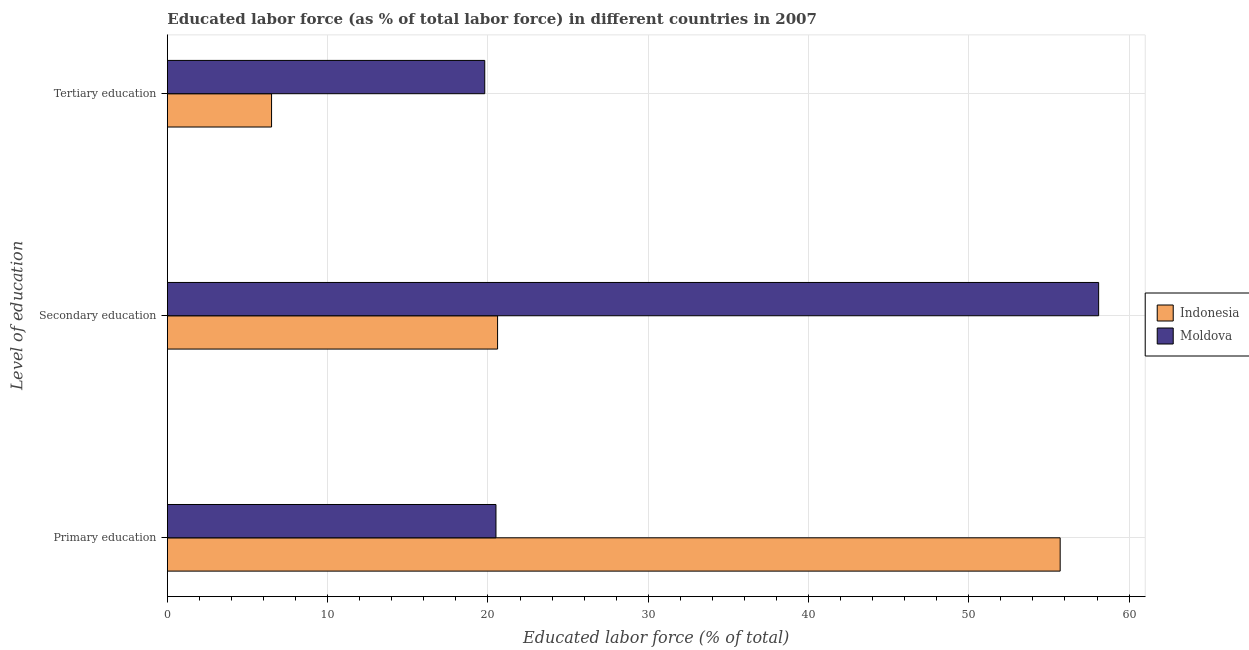Are the number of bars per tick equal to the number of legend labels?
Provide a short and direct response. Yes. Are the number of bars on each tick of the Y-axis equal?
Your response must be concise. Yes. How many bars are there on the 1st tick from the top?
Offer a very short reply. 2. How many bars are there on the 3rd tick from the bottom?
Keep it short and to the point. 2. What is the label of the 2nd group of bars from the top?
Offer a terse response. Secondary education. What is the percentage of labor force who received secondary education in Indonesia?
Make the answer very short. 20.6. Across all countries, what is the maximum percentage of labor force who received primary education?
Provide a short and direct response. 55.7. Across all countries, what is the minimum percentage of labor force who received tertiary education?
Offer a terse response. 6.5. In which country was the percentage of labor force who received secondary education maximum?
Provide a succinct answer. Moldova. In which country was the percentage of labor force who received primary education minimum?
Your answer should be compact. Moldova. What is the total percentage of labor force who received tertiary education in the graph?
Give a very brief answer. 26.3. What is the difference between the percentage of labor force who received primary education in Indonesia and that in Moldova?
Your answer should be very brief. 35.2. What is the difference between the percentage of labor force who received secondary education in Indonesia and the percentage of labor force who received primary education in Moldova?
Ensure brevity in your answer.  0.1. What is the average percentage of labor force who received secondary education per country?
Provide a succinct answer. 39.35. What is the difference between the percentage of labor force who received secondary education and percentage of labor force who received primary education in Moldova?
Your answer should be compact. 37.6. In how many countries, is the percentage of labor force who received primary education greater than 20 %?
Your response must be concise. 2. What is the ratio of the percentage of labor force who received secondary education in Moldova to that in Indonesia?
Ensure brevity in your answer.  2.82. Is the percentage of labor force who received secondary education in Moldova less than that in Indonesia?
Keep it short and to the point. No. Is the difference between the percentage of labor force who received secondary education in Moldova and Indonesia greater than the difference between the percentage of labor force who received tertiary education in Moldova and Indonesia?
Keep it short and to the point. Yes. What is the difference between the highest and the second highest percentage of labor force who received secondary education?
Offer a very short reply. 37.5. What is the difference between the highest and the lowest percentage of labor force who received tertiary education?
Keep it short and to the point. 13.3. Is the sum of the percentage of labor force who received secondary education in Moldova and Indonesia greater than the maximum percentage of labor force who received primary education across all countries?
Your response must be concise. Yes. What does the 1st bar from the top in Secondary education represents?
Offer a terse response. Moldova. What does the 2nd bar from the bottom in Secondary education represents?
Give a very brief answer. Moldova. Is it the case that in every country, the sum of the percentage of labor force who received primary education and percentage of labor force who received secondary education is greater than the percentage of labor force who received tertiary education?
Your response must be concise. Yes. Are all the bars in the graph horizontal?
Keep it short and to the point. Yes. How many countries are there in the graph?
Offer a terse response. 2. Does the graph contain grids?
Ensure brevity in your answer.  Yes. How are the legend labels stacked?
Your response must be concise. Vertical. What is the title of the graph?
Ensure brevity in your answer.  Educated labor force (as % of total labor force) in different countries in 2007. What is the label or title of the X-axis?
Your answer should be compact. Educated labor force (% of total). What is the label or title of the Y-axis?
Your response must be concise. Level of education. What is the Educated labor force (% of total) in Indonesia in Primary education?
Offer a very short reply. 55.7. What is the Educated labor force (% of total) in Indonesia in Secondary education?
Provide a succinct answer. 20.6. What is the Educated labor force (% of total) in Moldova in Secondary education?
Offer a terse response. 58.1. What is the Educated labor force (% of total) of Indonesia in Tertiary education?
Keep it short and to the point. 6.5. What is the Educated labor force (% of total) of Moldova in Tertiary education?
Offer a very short reply. 19.8. Across all Level of education, what is the maximum Educated labor force (% of total) of Indonesia?
Offer a terse response. 55.7. Across all Level of education, what is the maximum Educated labor force (% of total) of Moldova?
Give a very brief answer. 58.1. Across all Level of education, what is the minimum Educated labor force (% of total) in Indonesia?
Make the answer very short. 6.5. Across all Level of education, what is the minimum Educated labor force (% of total) of Moldova?
Keep it short and to the point. 19.8. What is the total Educated labor force (% of total) in Indonesia in the graph?
Your answer should be very brief. 82.8. What is the total Educated labor force (% of total) in Moldova in the graph?
Provide a succinct answer. 98.4. What is the difference between the Educated labor force (% of total) of Indonesia in Primary education and that in Secondary education?
Your response must be concise. 35.1. What is the difference between the Educated labor force (% of total) in Moldova in Primary education and that in Secondary education?
Provide a short and direct response. -37.6. What is the difference between the Educated labor force (% of total) in Indonesia in Primary education and that in Tertiary education?
Make the answer very short. 49.2. What is the difference between the Educated labor force (% of total) in Moldova in Secondary education and that in Tertiary education?
Offer a terse response. 38.3. What is the difference between the Educated labor force (% of total) in Indonesia in Primary education and the Educated labor force (% of total) in Moldova in Secondary education?
Provide a short and direct response. -2.4. What is the difference between the Educated labor force (% of total) of Indonesia in Primary education and the Educated labor force (% of total) of Moldova in Tertiary education?
Your answer should be compact. 35.9. What is the difference between the Educated labor force (% of total) of Indonesia in Secondary education and the Educated labor force (% of total) of Moldova in Tertiary education?
Offer a terse response. 0.8. What is the average Educated labor force (% of total) in Indonesia per Level of education?
Offer a terse response. 27.6. What is the average Educated labor force (% of total) in Moldova per Level of education?
Ensure brevity in your answer.  32.8. What is the difference between the Educated labor force (% of total) of Indonesia and Educated labor force (% of total) of Moldova in Primary education?
Give a very brief answer. 35.2. What is the difference between the Educated labor force (% of total) in Indonesia and Educated labor force (% of total) in Moldova in Secondary education?
Provide a succinct answer. -37.5. What is the ratio of the Educated labor force (% of total) in Indonesia in Primary education to that in Secondary education?
Make the answer very short. 2.7. What is the ratio of the Educated labor force (% of total) in Moldova in Primary education to that in Secondary education?
Offer a terse response. 0.35. What is the ratio of the Educated labor force (% of total) of Indonesia in Primary education to that in Tertiary education?
Offer a terse response. 8.57. What is the ratio of the Educated labor force (% of total) in Moldova in Primary education to that in Tertiary education?
Your response must be concise. 1.04. What is the ratio of the Educated labor force (% of total) in Indonesia in Secondary education to that in Tertiary education?
Offer a terse response. 3.17. What is the ratio of the Educated labor force (% of total) of Moldova in Secondary education to that in Tertiary education?
Ensure brevity in your answer.  2.93. What is the difference between the highest and the second highest Educated labor force (% of total) in Indonesia?
Give a very brief answer. 35.1. What is the difference between the highest and the second highest Educated labor force (% of total) in Moldova?
Ensure brevity in your answer.  37.6. What is the difference between the highest and the lowest Educated labor force (% of total) of Indonesia?
Ensure brevity in your answer.  49.2. What is the difference between the highest and the lowest Educated labor force (% of total) of Moldova?
Offer a very short reply. 38.3. 